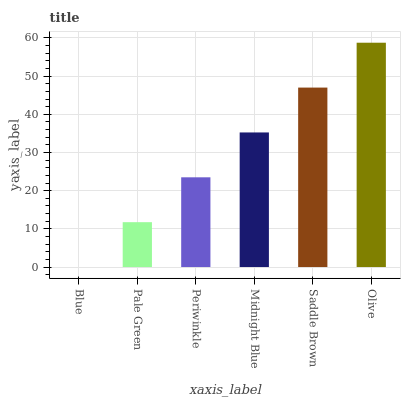Is Blue the minimum?
Answer yes or no. Yes. Is Olive the maximum?
Answer yes or no. Yes. Is Pale Green the minimum?
Answer yes or no. No. Is Pale Green the maximum?
Answer yes or no. No. Is Pale Green greater than Blue?
Answer yes or no. Yes. Is Blue less than Pale Green?
Answer yes or no. Yes. Is Blue greater than Pale Green?
Answer yes or no. No. Is Pale Green less than Blue?
Answer yes or no. No. Is Midnight Blue the high median?
Answer yes or no. Yes. Is Periwinkle the low median?
Answer yes or no. Yes. Is Periwinkle the high median?
Answer yes or no. No. Is Olive the low median?
Answer yes or no. No. 